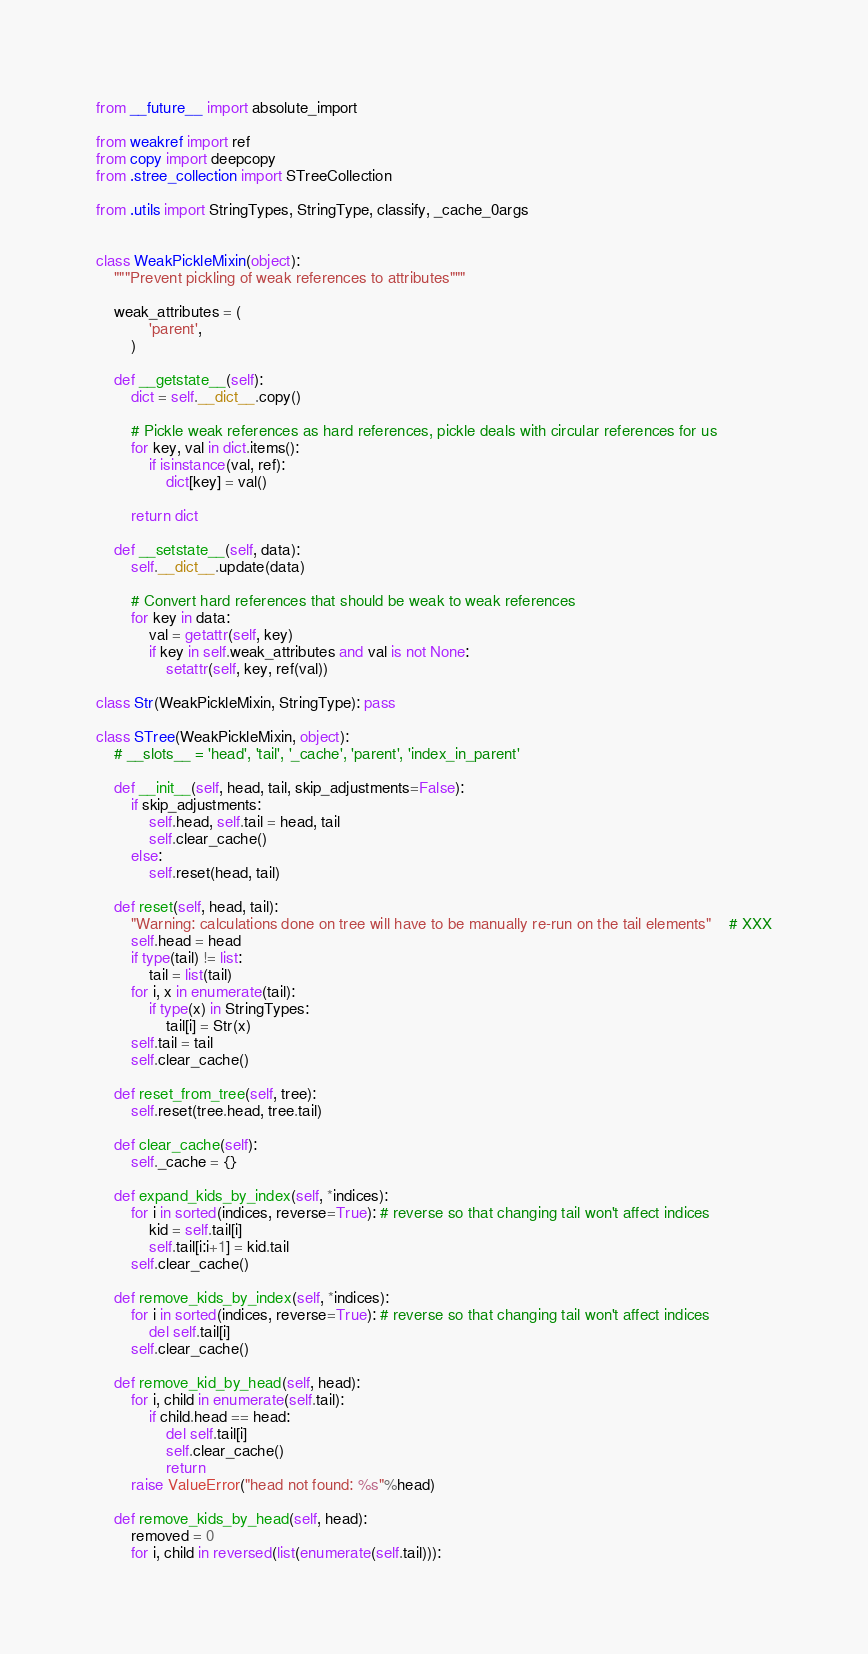<code> <loc_0><loc_0><loc_500><loc_500><_Python_>from __future__ import absolute_import

from weakref import ref
from copy import deepcopy
from .stree_collection import STreeCollection

from .utils import StringTypes, StringType, classify, _cache_0args


class WeakPickleMixin(object):
    """Prevent pickling of weak references to attributes"""

    weak_attributes = (
            'parent',
        )

    def __getstate__(self):
        dict = self.__dict__.copy()

        # Pickle weak references as hard references, pickle deals with circular references for us
        for key, val in dict.items():
            if isinstance(val, ref):
                dict[key] = val()

        return dict

    def __setstate__(self, data):
        self.__dict__.update(data)

        # Convert hard references that should be weak to weak references
        for key in data:
            val = getattr(self, key)
            if key in self.weak_attributes and val is not None:
                setattr(self, key, ref(val))

class Str(WeakPickleMixin, StringType): pass

class STree(WeakPickleMixin, object):
    # __slots__ = 'head', 'tail', '_cache', 'parent', 'index_in_parent'

    def __init__(self, head, tail, skip_adjustments=False):
        if skip_adjustments:
            self.head, self.tail = head, tail
            self.clear_cache()
        else:
            self.reset(head, tail)

    def reset(self, head, tail):
        "Warning: calculations done on tree will have to be manually re-run on the tail elements"    # XXX
        self.head = head
        if type(tail) != list:
            tail = list(tail)
        for i, x in enumerate(tail):
            if type(x) in StringTypes:
                tail[i] = Str(x)
        self.tail = tail
        self.clear_cache()

    def reset_from_tree(self, tree):
        self.reset(tree.head, tree.tail)

    def clear_cache(self):
        self._cache = {}

    def expand_kids_by_index(self, *indices):
        for i in sorted(indices, reverse=True): # reverse so that changing tail won't affect indices
            kid = self.tail[i]
            self.tail[i:i+1] = kid.tail
        self.clear_cache()

    def remove_kids_by_index(self, *indices):
        for i in sorted(indices, reverse=True): # reverse so that changing tail won't affect indices
            del self.tail[i]
        self.clear_cache()

    def remove_kid_by_head(self, head):
        for i, child in enumerate(self.tail):
            if child.head == head:
                del self.tail[i]
                self.clear_cache()
                return
        raise ValueError("head not found: %s"%head)

    def remove_kids_by_head(self, head):
        removed = 0
        for i, child in reversed(list(enumerate(self.tail))):</code> 